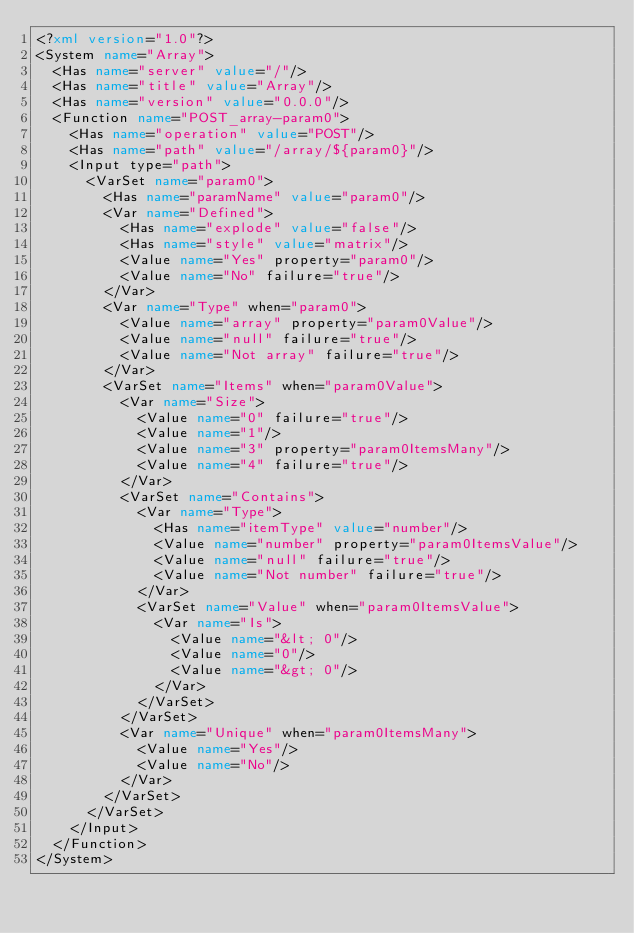<code> <loc_0><loc_0><loc_500><loc_500><_XML_><?xml version="1.0"?>
<System name="Array">
  <Has name="server" value="/"/>
  <Has name="title" value="Array"/>
  <Has name="version" value="0.0.0"/>
  <Function name="POST_array-param0">
    <Has name="operation" value="POST"/>
    <Has name="path" value="/array/${param0}"/>
    <Input type="path">
      <VarSet name="param0">
        <Has name="paramName" value="param0"/>
        <Var name="Defined">
          <Has name="explode" value="false"/>
          <Has name="style" value="matrix"/>
          <Value name="Yes" property="param0"/>
          <Value name="No" failure="true"/>
        </Var>
        <Var name="Type" when="param0">
          <Value name="array" property="param0Value"/>
          <Value name="null" failure="true"/>
          <Value name="Not array" failure="true"/>
        </Var>
        <VarSet name="Items" when="param0Value">
          <Var name="Size">
            <Value name="0" failure="true"/>
            <Value name="1"/>
            <Value name="3" property="param0ItemsMany"/>
            <Value name="4" failure="true"/>
          </Var>
          <VarSet name="Contains">
            <Var name="Type">
              <Has name="itemType" value="number"/>
              <Value name="number" property="param0ItemsValue"/>
              <Value name="null" failure="true"/>
              <Value name="Not number" failure="true"/>
            </Var>
            <VarSet name="Value" when="param0ItemsValue">
              <Var name="Is">
                <Value name="&lt; 0"/>
                <Value name="0"/>
                <Value name="&gt; 0"/>
              </Var>
            </VarSet>
          </VarSet>
          <Var name="Unique" when="param0ItemsMany">
            <Value name="Yes"/>
            <Value name="No"/>
          </Var>
        </VarSet>
      </VarSet>
    </Input>
  </Function>
</System>
</code> 